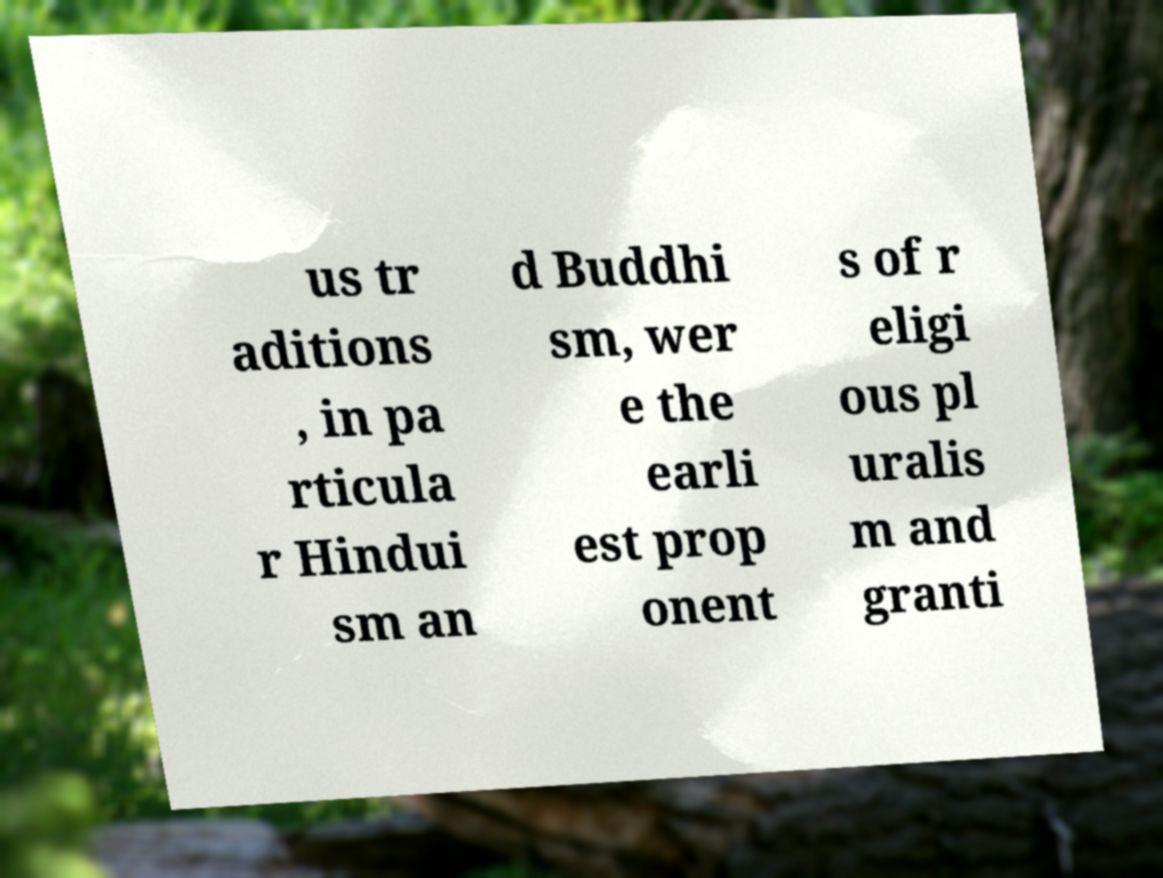I need the written content from this picture converted into text. Can you do that? us tr aditions , in pa rticula r Hindui sm an d Buddhi sm, wer e the earli est prop onent s of r eligi ous pl uralis m and granti 